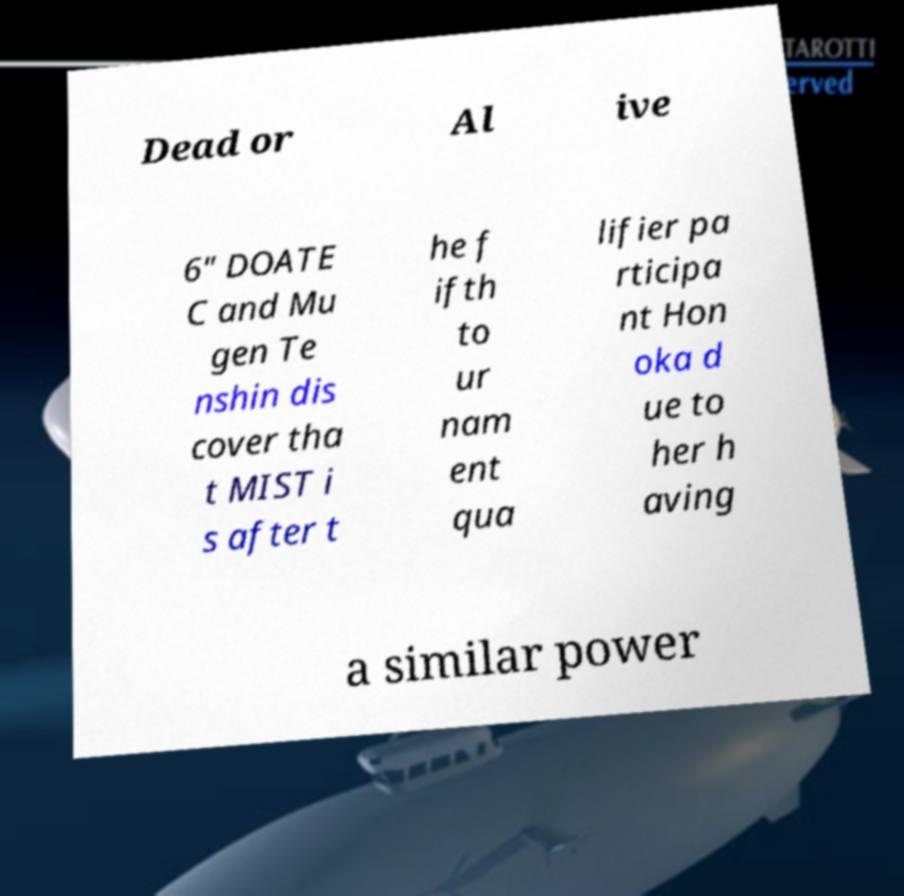For documentation purposes, I need the text within this image transcribed. Could you provide that? Dead or Al ive 6" DOATE C and Mu gen Te nshin dis cover tha t MIST i s after t he f ifth to ur nam ent qua lifier pa rticipa nt Hon oka d ue to her h aving a similar power 